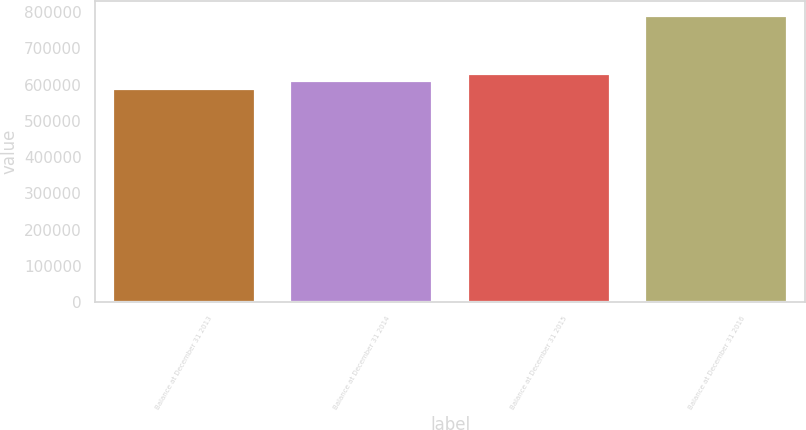<chart> <loc_0><loc_0><loc_500><loc_500><bar_chart><fcel>Balance at December 31 2013<fcel>Balance at December 31 2014<fcel>Balance at December 31 2015<fcel>Balance at December 31 2016<nl><fcel>588471<fcel>608648<fcel>628825<fcel>790243<nl></chart> 